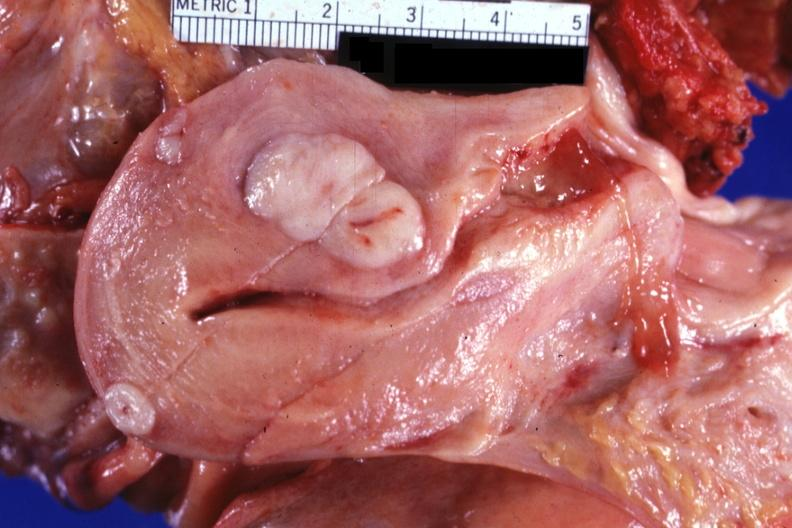what is present?
Answer the question using a single word or phrase. Leiomyomas 